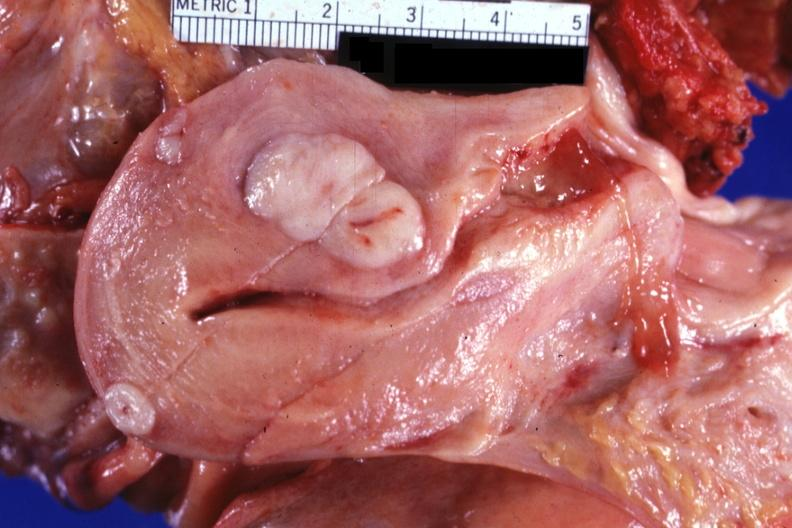what is present?
Answer the question using a single word or phrase. Leiomyomas 